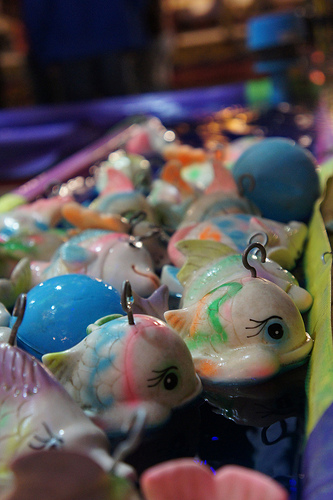<image>
Is the toy to the left of the toy? Yes. From this viewpoint, the toy is positioned to the left side relative to the toy. 